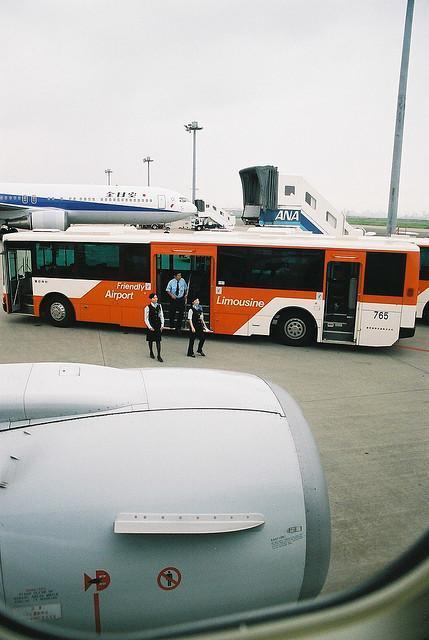How many men are in this picture?
Give a very brief answer. 3. How many airplanes can be seen?
Give a very brief answer. 2. How many sinks are to the right of the shower?
Give a very brief answer. 0. 